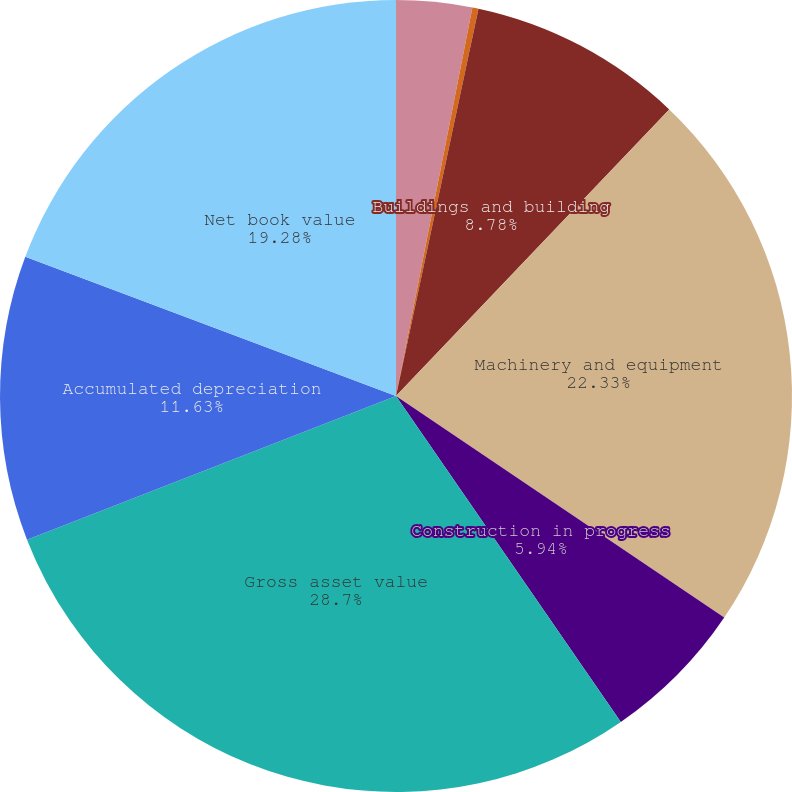Convert chart to OTSL. <chart><loc_0><loc_0><loc_500><loc_500><pie_chart><fcel>Land<fcel>Land improvements<fcel>Buildings and building<fcel>Machinery and equipment<fcel>Construction in progress<fcel>Gross asset value<fcel>Accumulated depreciation<fcel>Net book value<nl><fcel>3.09%<fcel>0.25%<fcel>8.78%<fcel>22.33%<fcel>5.94%<fcel>28.7%<fcel>11.63%<fcel>19.28%<nl></chart> 